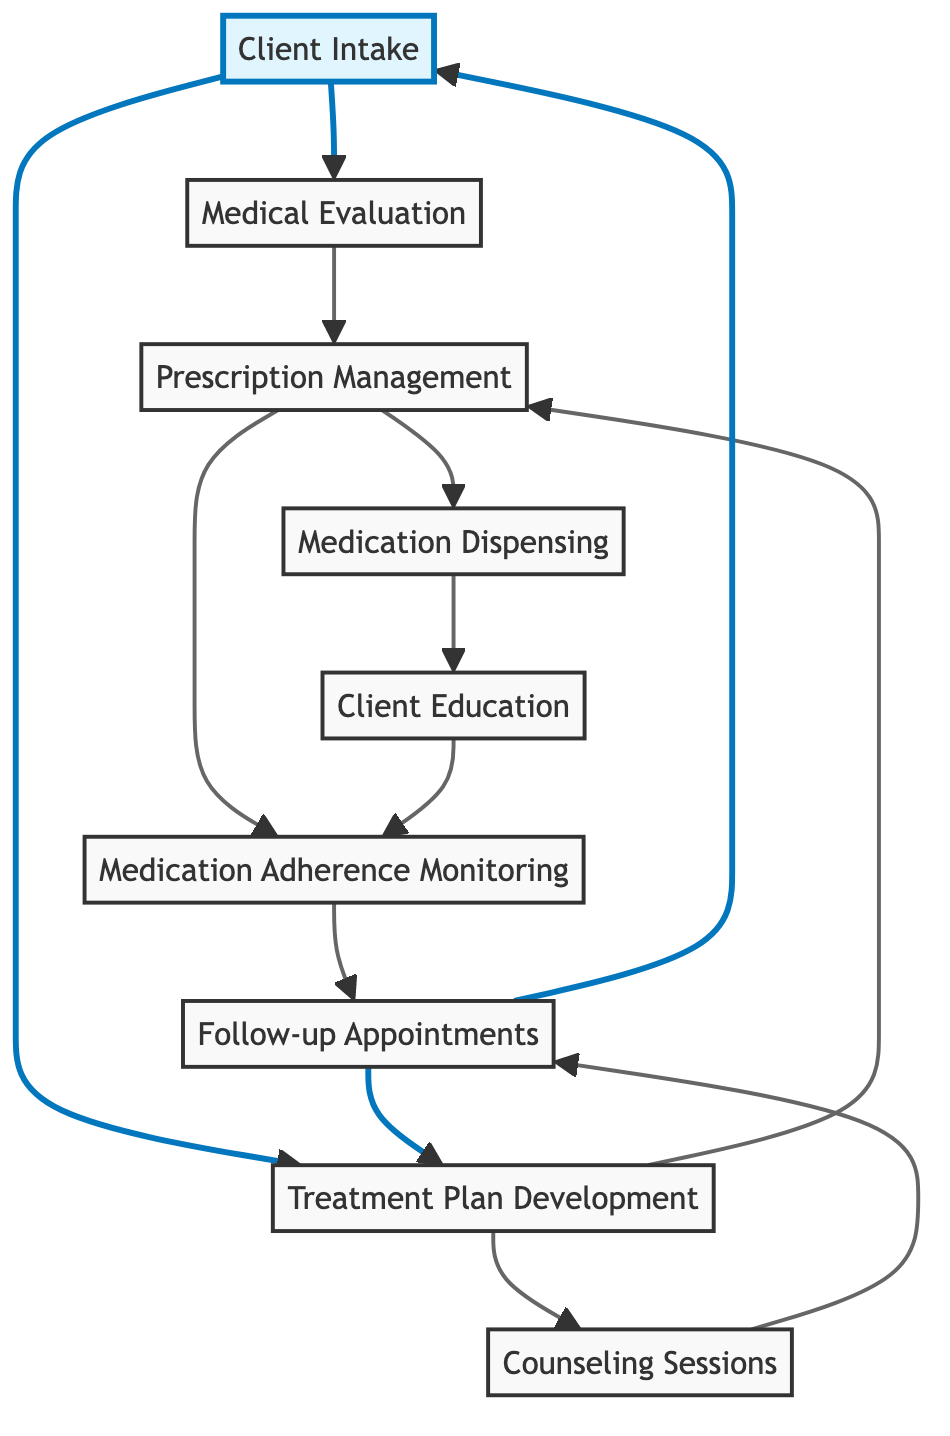What is the first step in the medication management workflow? The first step is "Client Intake," where an initial meeting is held to assess the medical and psychological needs of the client.
Answer: Client Intake How many nodes are there in the flow chart? There are eight nodes representing different steps in the medication management workflow.
Answer: Eight Which node comes after "Medical Evaluation"? After "Medical Evaluation," the next node is "Prescription Management." This is shown by the direct connection from Medical Evaluation to Prescription Management.
Answer: Prescription Management What are the two connections from "Treatment Plan Development"? The two connections from "Treatment Plan Development" are to "Prescription Management" and "Counseling Sessions," indicating the flow to these related activities.
Answer: Prescription Management, Counseling Sessions What is the output of "Prescription Management"? The output of "Prescription Management" leads to "Medication Dispensing" and "Medication Adherence Monitoring," reflecting the management activities performed by healthcare providers.
Answer: Medication Dispensing, Medication Adherence Monitoring How does "Client Education" relate to "Medication Adherence Monitoring"? "Client Education" directly connects to "Medication Adherence Monitoring," indicating that educating clients about their medications is linked to monitoring adherence.
Answer: Direct connection What is the final step that loops back to the beginning of the workflow? The final step that loops back to the beginning is "Follow-up Appointments," which connects back to "Client Intake" and "Treatment Plan Development" for continuous client management.
Answer: Follow-up Appointments Which node is directly connected to both "Counseling Sessions" and "Medication Adherence Monitoring"? "Follow-up Appointments" is the node that connects directly to both "Counseling Sessions" and "Medication Adherence Monitoring," indicating its role in reviewing client progress in both areas.
Answer: Follow-up Appointments 